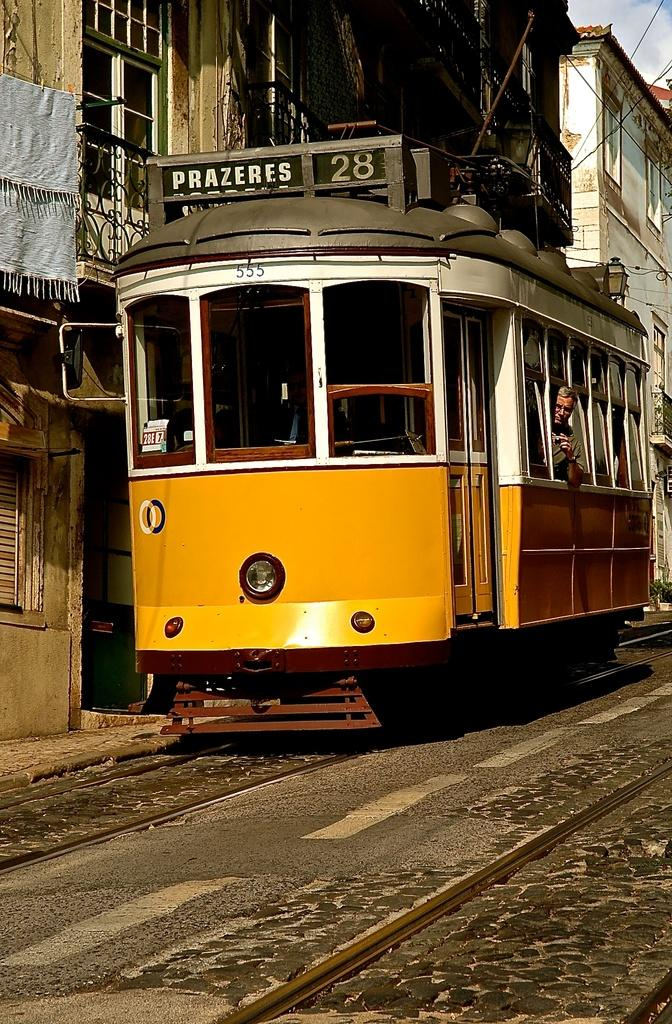What is inside the vehicle in the image? There is a person inside the vehicle. What can be seen in the background of the image? There are buildings visible in the image. What type of material is visible in the image? There is cloth visible in the image. What allows light to enter the vehicle and provides a view of the surroundings? There are windows in the image. What type of substance is being poured from the vase in the image? There is no vase or substance present in the image. How many roses can be seen in the image? There are no roses present in the image. 